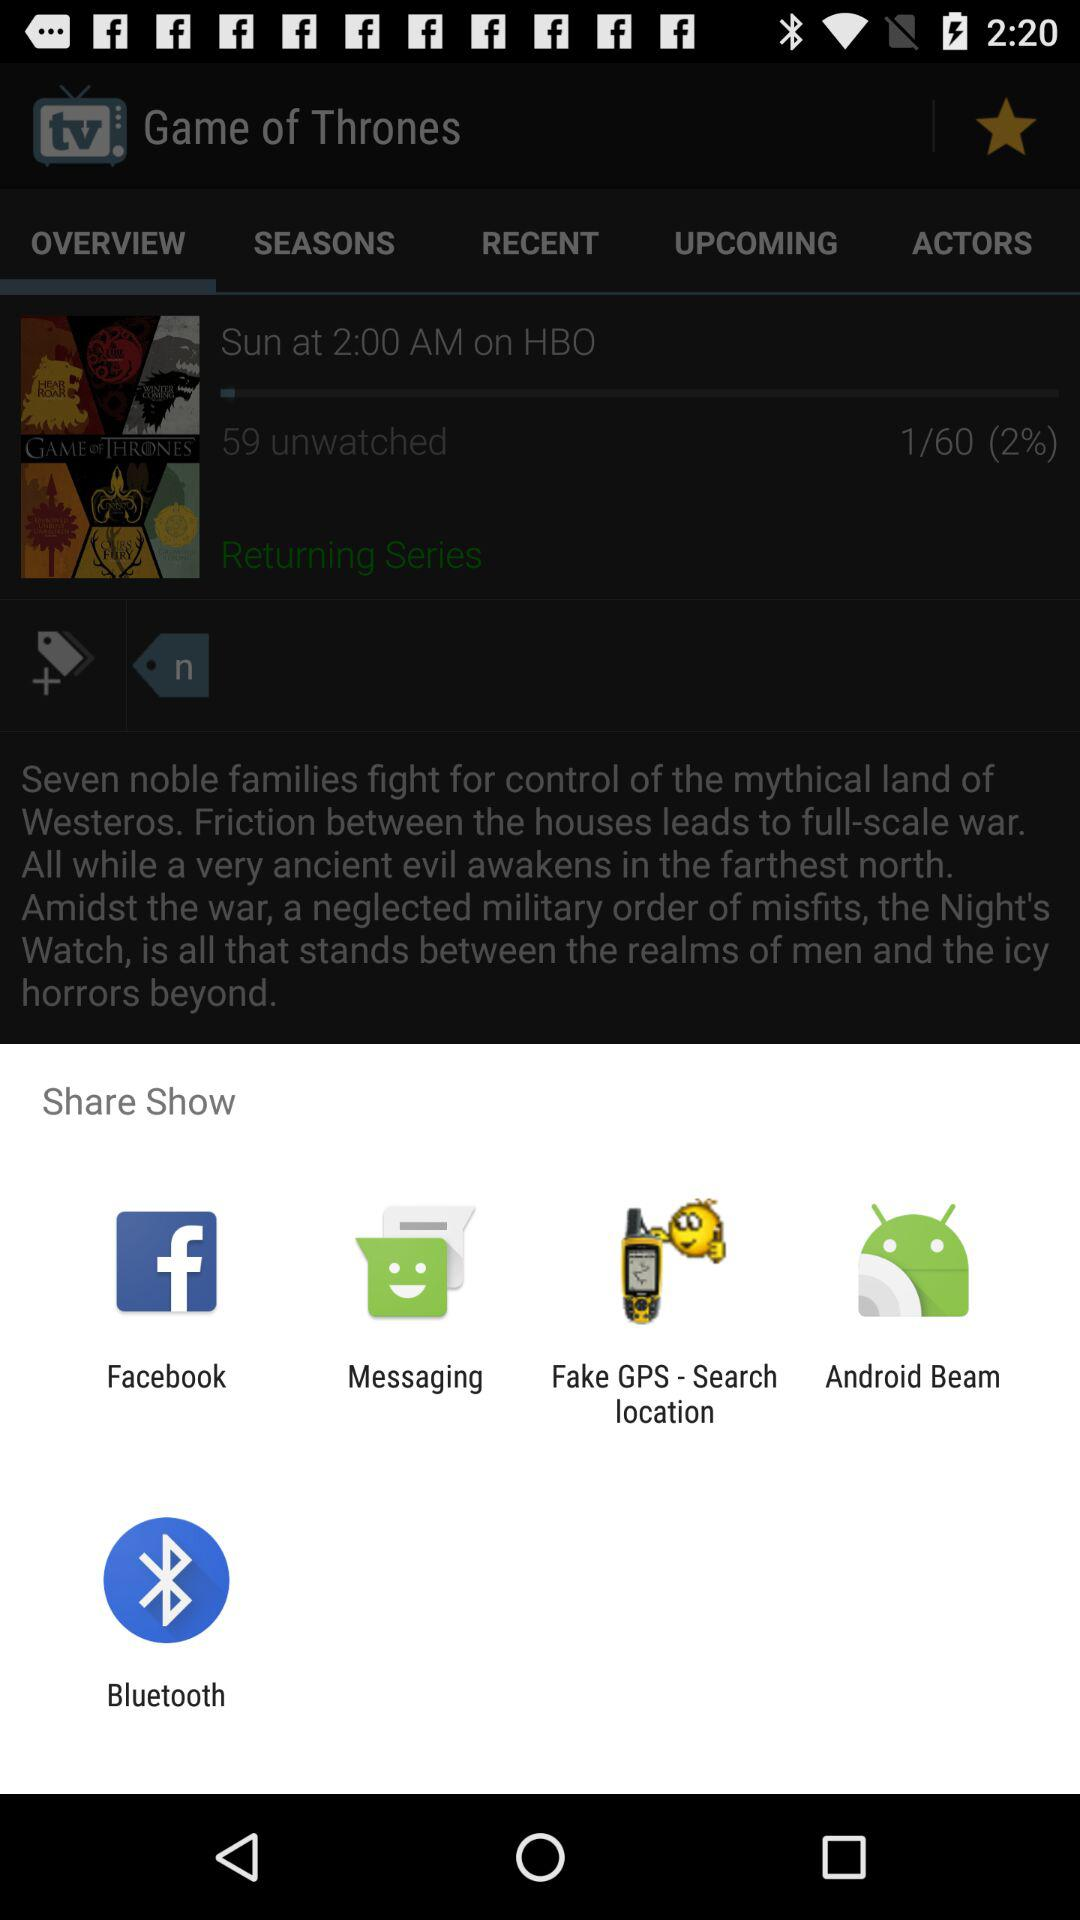What application is used to share? The applications are "Facebook", "Messaging", "Fake GPS - Search location", "Android Beam" and "Bluetooth". 